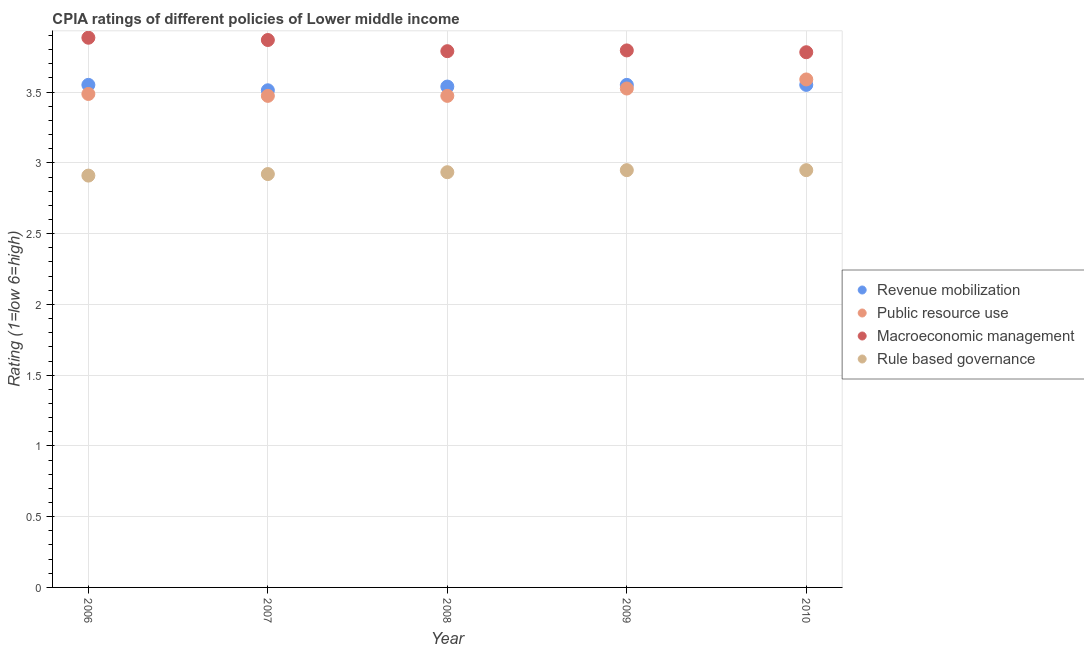What is the cpia rating of macroeconomic management in 2010?
Give a very brief answer. 3.78. Across all years, what is the maximum cpia rating of public resource use?
Your answer should be compact. 3.59. Across all years, what is the minimum cpia rating of revenue mobilization?
Your answer should be very brief. 3.51. In which year was the cpia rating of macroeconomic management maximum?
Keep it short and to the point. 2006. What is the total cpia rating of rule based governance in the graph?
Your answer should be compact. 14.66. What is the difference between the cpia rating of public resource use in 2008 and that in 2010?
Offer a very short reply. -0.12. What is the difference between the cpia rating of public resource use in 2007 and the cpia rating of macroeconomic management in 2009?
Give a very brief answer. -0.32. What is the average cpia rating of public resource use per year?
Your answer should be compact. 3.51. In the year 2007, what is the difference between the cpia rating of public resource use and cpia rating of macroeconomic management?
Provide a short and direct response. -0.39. What is the ratio of the cpia rating of rule based governance in 2007 to that in 2009?
Offer a terse response. 0.99. Is the cpia rating of macroeconomic management in 2006 less than that in 2007?
Offer a very short reply. No. Is the difference between the cpia rating of rule based governance in 2006 and 2010 greater than the difference between the cpia rating of macroeconomic management in 2006 and 2010?
Make the answer very short. No. What is the difference between the highest and the lowest cpia rating of rule based governance?
Offer a terse response. 0.04. Is it the case that in every year, the sum of the cpia rating of public resource use and cpia rating of rule based governance is greater than the sum of cpia rating of macroeconomic management and cpia rating of revenue mobilization?
Ensure brevity in your answer.  No. Is it the case that in every year, the sum of the cpia rating of revenue mobilization and cpia rating of public resource use is greater than the cpia rating of macroeconomic management?
Provide a short and direct response. Yes. How many years are there in the graph?
Keep it short and to the point. 5. Are the values on the major ticks of Y-axis written in scientific E-notation?
Offer a very short reply. No. How many legend labels are there?
Give a very brief answer. 4. How are the legend labels stacked?
Offer a very short reply. Vertical. What is the title of the graph?
Provide a short and direct response. CPIA ratings of different policies of Lower middle income. What is the label or title of the X-axis?
Give a very brief answer. Year. What is the label or title of the Y-axis?
Keep it short and to the point. Rating (1=low 6=high). What is the Rating (1=low 6=high) of Revenue mobilization in 2006?
Offer a very short reply. 3.55. What is the Rating (1=low 6=high) of Public resource use in 2006?
Keep it short and to the point. 3.49. What is the Rating (1=low 6=high) in Macroeconomic management in 2006?
Your answer should be compact. 3.88. What is the Rating (1=low 6=high) of Rule based governance in 2006?
Your response must be concise. 2.91. What is the Rating (1=low 6=high) of Revenue mobilization in 2007?
Offer a terse response. 3.51. What is the Rating (1=low 6=high) of Public resource use in 2007?
Your answer should be compact. 3.47. What is the Rating (1=low 6=high) in Macroeconomic management in 2007?
Ensure brevity in your answer.  3.87. What is the Rating (1=low 6=high) of Rule based governance in 2007?
Your response must be concise. 2.92. What is the Rating (1=low 6=high) in Revenue mobilization in 2008?
Offer a very short reply. 3.54. What is the Rating (1=low 6=high) in Public resource use in 2008?
Offer a very short reply. 3.47. What is the Rating (1=low 6=high) of Macroeconomic management in 2008?
Make the answer very short. 3.79. What is the Rating (1=low 6=high) of Rule based governance in 2008?
Your answer should be compact. 2.93. What is the Rating (1=low 6=high) of Revenue mobilization in 2009?
Keep it short and to the point. 3.55. What is the Rating (1=low 6=high) of Public resource use in 2009?
Offer a terse response. 3.53. What is the Rating (1=low 6=high) of Macroeconomic management in 2009?
Give a very brief answer. 3.79. What is the Rating (1=low 6=high) of Rule based governance in 2009?
Provide a short and direct response. 2.95. What is the Rating (1=low 6=high) of Revenue mobilization in 2010?
Ensure brevity in your answer.  3.55. What is the Rating (1=low 6=high) of Public resource use in 2010?
Offer a terse response. 3.59. What is the Rating (1=low 6=high) in Macroeconomic management in 2010?
Your answer should be compact. 3.78. What is the Rating (1=low 6=high) of Rule based governance in 2010?
Offer a terse response. 2.95. Across all years, what is the maximum Rating (1=low 6=high) in Revenue mobilization?
Ensure brevity in your answer.  3.55. Across all years, what is the maximum Rating (1=low 6=high) in Public resource use?
Give a very brief answer. 3.59. Across all years, what is the maximum Rating (1=low 6=high) in Macroeconomic management?
Offer a very short reply. 3.88. Across all years, what is the maximum Rating (1=low 6=high) of Rule based governance?
Your answer should be very brief. 2.95. Across all years, what is the minimum Rating (1=low 6=high) in Revenue mobilization?
Make the answer very short. 3.51. Across all years, what is the minimum Rating (1=low 6=high) in Public resource use?
Make the answer very short. 3.47. Across all years, what is the minimum Rating (1=low 6=high) in Macroeconomic management?
Make the answer very short. 3.78. Across all years, what is the minimum Rating (1=low 6=high) of Rule based governance?
Give a very brief answer. 2.91. What is the total Rating (1=low 6=high) of Revenue mobilization in the graph?
Your answer should be compact. 17.71. What is the total Rating (1=low 6=high) in Public resource use in the graph?
Give a very brief answer. 17.55. What is the total Rating (1=low 6=high) of Macroeconomic management in the graph?
Ensure brevity in your answer.  19.12. What is the total Rating (1=low 6=high) in Rule based governance in the graph?
Ensure brevity in your answer.  14.66. What is the difference between the Rating (1=low 6=high) of Revenue mobilization in 2006 and that in 2007?
Offer a very short reply. 0.04. What is the difference between the Rating (1=low 6=high) in Public resource use in 2006 and that in 2007?
Keep it short and to the point. 0.01. What is the difference between the Rating (1=low 6=high) in Macroeconomic management in 2006 and that in 2007?
Provide a short and direct response. 0.02. What is the difference between the Rating (1=low 6=high) of Rule based governance in 2006 and that in 2007?
Provide a succinct answer. -0.01. What is the difference between the Rating (1=low 6=high) of Revenue mobilization in 2006 and that in 2008?
Offer a very short reply. 0.01. What is the difference between the Rating (1=low 6=high) of Public resource use in 2006 and that in 2008?
Your response must be concise. 0.01. What is the difference between the Rating (1=low 6=high) of Macroeconomic management in 2006 and that in 2008?
Give a very brief answer. 0.1. What is the difference between the Rating (1=low 6=high) in Rule based governance in 2006 and that in 2008?
Keep it short and to the point. -0.02. What is the difference between the Rating (1=low 6=high) in Revenue mobilization in 2006 and that in 2009?
Make the answer very short. 0. What is the difference between the Rating (1=low 6=high) in Public resource use in 2006 and that in 2009?
Offer a very short reply. -0.04. What is the difference between the Rating (1=low 6=high) of Macroeconomic management in 2006 and that in 2009?
Offer a terse response. 0.09. What is the difference between the Rating (1=low 6=high) of Rule based governance in 2006 and that in 2009?
Your answer should be very brief. -0.04. What is the difference between the Rating (1=low 6=high) in Revenue mobilization in 2006 and that in 2010?
Keep it short and to the point. 0. What is the difference between the Rating (1=low 6=high) in Public resource use in 2006 and that in 2010?
Provide a short and direct response. -0.1. What is the difference between the Rating (1=low 6=high) of Macroeconomic management in 2006 and that in 2010?
Offer a terse response. 0.1. What is the difference between the Rating (1=low 6=high) of Rule based governance in 2006 and that in 2010?
Provide a short and direct response. -0.04. What is the difference between the Rating (1=low 6=high) in Revenue mobilization in 2007 and that in 2008?
Offer a terse response. -0.03. What is the difference between the Rating (1=low 6=high) in Macroeconomic management in 2007 and that in 2008?
Ensure brevity in your answer.  0.08. What is the difference between the Rating (1=low 6=high) of Rule based governance in 2007 and that in 2008?
Give a very brief answer. -0.01. What is the difference between the Rating (1=low 6=high) of Revenue mobilization in 2007 and that in 2009?
Make the answer very short. -0.04. What is the difference between the Rating (1=low 6=high) in Public resource use in 2007 and that in 2009?
Offer a very short reply. -0.05. What is the difference between the Rating (1=low 6=high) of Macroeconomic management in 2007 and that in 2009?
Ensure brevity in your answer.  0.07. What is the difference between the Rating (1=low 6=high) of Rule based governance in 2007 and that in 2009?
Give a very brief answer. -0.03. What is the difference between the Rating (1=low 6=high) of Revenue mobilization in 2007 and that in 2010?
Provide a short and direct response. -0.04. What is the difference between the Rating (1=low 6=high) in Public resource use in 2007 and that in 2010?
Provide a short and direct response. -0.12. What is the difference between the Rating (1=low 6=high) of Macroeconomic management in 2007 and that in 2010?
Offer a very short reply. 0.09. What is the difference between the Rating (1=low 6=high) in Rule based governance in 2007 and that in 2010?
Ensure brevity in your answer.  -0.03. What is the difference between the Rating (1=low 6=high) in Revenue mobilization in 2008 and that in 2009?
Ensure brevity in your answer.  -0.01. What is the difference between the Rating (1=low 6=high) in Public resource use in 2008 and that in 2009?
Your response must be concise. -0.05. What is the difference between the Rating (1=low 6=high) of Macroeconomic management in 2008 and that in 2009?
Your answer should be compact. -0.01. What is the difference between the Rating (1=low 6=high) in Rule based governance in 2008 and that in 2009?
Offer a terse response. -0.01. What is the difference between the Rating (1=low 6=high) in Revenue mobilization in 2008 and that in 2010?
Your response must be concise. -0.01. What is the difference between the Rating (1=low 6=high) of Public resource use in 2008 and that in 2010?
Offer a very short reply. -0.12. What is the difference between the Rating (1=low 6=high) of Macroeconomic management in 2008 and that in 2010?
Ensure brevity in your answer.  0.01. What is the difference between the Rating (1=low 6=high) in Rule based governance in 2008 and that in 2010?
Provide a succinct answer. -0.01. What is the difference between the Rating (1=low 6=high) in Revenue mobilization in 2009 and that in 2010?
Keep it short and to the point. 0. What is the difference between the Rating (1=low 6=high) of Public resource use in 2009 and that in 2010?
Offer a terse response. -0.06. What is the difference between the Rating (1=low 6=high) of Macroeconomic management in 2009 and that in 2010?
Give a very brief answer. 0.01. What is the difference between the Rating (1=low 6=high) in Revenue mobilization in 2006 and the Rating (1=low 6=high) in Public resource use in 2007?
Provide a succinct answer. 0.08. What is the difference between the Rating (1=low 6=high) of Revenue mobilization in 2006 and the Rating (1=low 6=high) of Macroeconomic management in 2007?
Your answer should be very brief. -0.32. What is the difference between the Rating (1=low 6=high) in Revenue mobilization in 2006 and the Rating (1=low 6=high) in Rule based governance in 2007?
Offer a very short reply. 0.63. What is the difference between the Rating (1=low 6=high) of Public resource use in 2006 and the Rating (1=low 6=high) of Macroeconomic management in 2007?
Provide a succinct answer. -0.38. What is the difference between the Rating (1=low 6=high) of Public resource use in 2006 and the Rating (1=low 6=high) of Rule based governance in 2007?
Keep it short and to the point. 0.57. What is the difference between the Rating (1=low 6=high) of Macroeconomic management in 2006 and the Rating (1=low 6=high) of Rule based governance in 2007?
Ensure brevity in your answer.  0.96. What is the difference between the Rating (1=low 6=high) of Revenue mobilization in 2006 and the Rating (1=low 6=high) of Public resource use in 2008?
Your answer should be very brief. 0.08. What is the difference between the Rating (1=low 6=high) of Revenue mobilization in 2006 and the Rating (1=low 6=high) of Macroeconomic management in 2008?
Give a very brief answer. -0.24. What is the difference between the Rating (1=low 6=high) in Revenue mobilization in 2006 and the Rating (1=low 6=high) in Rule based governance in 2008?
Make the answer very short. 0.62. What is the difference between the Rating (1=low 6=high) of Public resource use in 2006 and the Rating (1=low 6=high) of Macroeconomic management in 2008?
Your answer should be compact. -0.3. What is the difference between the Rating (1=low 6=high) in Public resource use in 2006 and the Rating (1=low 6=high) in Rule based governance in 2008?
Provide a short and direct response. 0.55. What is the difference between the Rating (1=low 6=high) of Macroeconomic management in 2006 and the Rating (1=low 6=high) of Rule based governance in 2008?
Your response must be concise. 0.95. What is the difference between the Rating (1=low 6=high) of Revenue mobilization in 2006 and the Rating (1=low 6=high) of Public resource use in 2009?
Your answer should be very brief. 0.03. What is the difference between the Rating (1=low 6=high) in Revenue mobilization in 2006 and the Rating (1=low 6=high) in Macroeconomic management in 2009?
Your answer should be compact. -0.24. What is the difference between the Rating (1=low 6=high) of Revenue mobilization in 2006 and the Rating (1=low 6=high) of Rule based governance in 2009?
Your response must be concise. 0.6. What is the difference between the Rating (1=low 6=high) in Public resource use in 2006 and the Rating (1=low 6=high) in Macroeconomic management in 2009?
Provide a succinct answer. -0.31. What is the difference between the Rating (1=low 6=high) in Public resource use in 2006 and the Rating (1=low 6=high) in Rule based governance in 2009?
Give a very brief answer. 0.54. What is the difference between the Rating (1=low 6=high) in Macroeconomic management in 2006 and the Rating (1=low 6=high) in Rule based governance in 2009?
Give a very brief answer. 0.94. What is the difference between the Rating (1=low 6=high) of Revenue mobilization in 2006 and the Rating (1=low 6=high) of Public resource use in 2010?
Your answer should be very brief. -0.04. What is the difference between the Rating (1=low 6=high) in Revenue mobilization in 2006 and the Rating (1=low 6=high) in Macroeconomic management in 2010?
Keep it short and to the point. -0.23. What is the difference between the Rating (1=low 6=high) of Revenue mobilization in 2006 and the Rating (1=low 6=high) of Rule based governance in 2010?
Offer a terse response. 0.6. What is the difference between the Rating (1=low 6=high) of Public resource use in 2006 and the Rating (1=low 6=high) of Macroeconomic management in 2010?
Your answer should be compact. -0.29. What is the difference between the Rating (1=low 6=high) in Public resource use in 2006 and the Rating (1=low 6=high) in Rule based governance in 2010?
Provide a succinct answer. 0.54. What is the difference between the Rating (1=low 6=high) of Macroeconomic management in 2006 and the Rating (1=low 6=high) of Rule based governance in 2010?
Your answer should be compact. 0.94. What is the difference between the Rating (1=low 6=high) of Revenue mobilization in 2007 and the Rating (1=low 6=high) of Public resource use in 2008?
Your answer should be very brief. 0.04. What is the difference between the Rating (1=low 6=high) of Revenue mobilization in 2007 and the Rating (1=low 6=high) of Macroeconomic management in 2008?
Offer a terse response. -0.28. What is the difference between the Rating (1=low 6=high) of Revenue mobilization in 2007 and the Rating (1=low 6=high) of Rule based governance in 2008?
Ensure brevity in your answer.  0.58. What is the difference between the Rating (1=low 6=high) in Public resource use in 2007 and the Rating (1=low 6=high) in Macroeconomic management in 2008?
Make the answer very short. -0.32. What is the difference between the Rating (1=low 6=high) of Public resource use in 2007 and the Rating (1=low 6=high) of Rule based governance in 2008?
Your answer should be compact. 0.54. What is the difference between the Rating (1=low 6=high) in Macroeconomic management in 2007 and the Rating (1=low 6=high) in Rule based governance in 2008?
Give a very brief answer. 0.93. What is the difference between the Rating (1=low 6=high) in Revenue mobilization in 2007 and the Rating (1=low 6=high) in Public resource use in 2009?
Your response must be concise. -0.01. What is the difference between the Rating (1=low 6=high) in Revenue mobilization in 2007 and the Rating (1=low 6=high) in Macroeconomic management in 2009?
Offer a very short reply. -0.28. What is the difference between the Rating (1=low 6=high) of Revenue mobilization in 2007 and the Rating (1=low 6=high) of Rule based governance in 2009?
Provide a succinct answer. 0.56. What is the difference between the Rating (1=low 6=high) of Public resource use in 2007 and the Rating (1=low 6=high) of Macroeconomic management in 2009?
Keep it short and to the point. -0.32. What is the difference between the Rating (1=low 6=high) of Public resource use in 2007 and the Rating (1=low 6=high) of Rule based governance in 2009?
Offer a terse response. 0.53. What is the difference between the Rating (1=low 6=high) in Macroeconomic management in 2007 and the Rating (1=low 6=high) in Rule based governance in 2009?
Give a very brief answer. 0.92. What is the difference between the Rating (1=low 6=high) in Revenue mobilization in 2007 and the Rating (1=low 6=high) in Public resource use in 2010?
Offer a very short reply. -0.08. What is the difference between the Rating (1=low 6=high) of Revenue mobilization in 2007 and the Rating (1=low 6=high) of Macroeconomic management in 2010?
Offer a terse response. -0.27. What is the difference between the Rating (1=low 6=high) in Revenue mobilization in 2007 and the Rating (1=low 6=high) in Rule based governance in 2010?
Give a very brief answer. 0.56. What is the difference between the Rating (1=low 6=high) in Public resource use in 2007 and the Rating (1=low 6=high) in Macroeconomic management in 2010?
Your answer should be very brief. -0.31. What is the difference between the Rating (1=low 6=high) of Public resource use in 2007 and the Rating (1=low 6=high) of Rule based governance in 2010?
Ensure brevity in your answer.  0.53. What is the difference between the Rating (1=low 6=high) in Macroeconomic management in 2007 and the Rating (1=low 6=high) in Rule based governance in 2010?
Your response must be concise. 0.92. What is the difference between the Rating (1=low 6=high) in Revenue mobilization in 2008 and the Rating (1=low 6=high) in Public resource use in 2009?
Your answer should be compact. 0.01. What is the difference between the Rating (1=low 6=high) of Revenue mobilization in 2008 and the Rating (1=low 6=high) of Macroeconomic management in 2009?
Provide a short and direct response. -0.26. What is the difference between the Rating (1=low 6=high) in Revenue mobilization in 2008 and the Rating (1=low 6=high) in Rule based governance in 2009?
Give a very brief answer. 0.59. What is the difference between the Rating (1=low 6=high) in Public resource use in 2008 and the Rating (1=low 6=high) in Macroeconomic management in 2009?
Make the answer very short. -0.32. What is the difference between the Rating (1=low 6=high) of Public resource use in 2008 and the Rating (1=low 6=high) of Rule based governance in 2009?
Offer a terse response. 0.53. What is the difference between the Rating (1=low 6=high) of Macroeconomic management in 2008 and the Rating (1=low 6=high) of Rule based governance in 2009?
Offer a terse response. 0.84. What is the difference between the Rating (1=low 6=high) of Revenue mobilization in 2008 and the Rating (1=low 6=high) of Public resource use in 2010?
Keep it short and to the point. -0.05. What is the difference between the Rating (1=low 6=high) of Revenue mobilization in 2008 and the Rating (1=low 6=high) of Macroeconomic management in 2010?
Your response must be concise. -0.24. What is the difference between the Rating (1=low 6=high) of Revenue mobilization in 2008 and the Rating (1=low 6=high) of Rule based governance in 2010?
Offer a terse response. 0.59. What is the difference between the Rating (1=low 6=high) in Public resource use in 2008 and the Rating (1=low 6=high) in Macroeconomic management in 2010?
Provide a short and direct response. -0.31. What is the difference between the Rating (1=low 6=high) of Public resource use in 2008 and the Rating (1=low 6=high) of Rule based governance in 2010?
Offer a terse response. 0.53. What is the difference between the Rating (1=low 6=high) of Macroeconomic management in 2008 and the Rating (1=low 6=high) of Rule based governance in 2010?
Your answer should be compact. 0.84. What is the difference between the Rating (1=low 6=high) in Revenue mobilization in 2009 and the Rating (1=low 6=high) in Public resource use in 2010?
Offer a very short reply. -0.04. What is the difference between the Rating (1=low 6=high) of Revenue mobilization in 2009 and the Rating (1=low 6=high) of Macroeconomic management in 2010?
Give a very brief answer. -0.23. What is the difference between the Rating (1=low 6=high) of Revenue mobilization in 2009 and the Rating (1=low 6=high) of Rule based governance in 2010?
Offer a terse response. 0.6. What is the difference between the Rating (1=low 6=high) of Public resource use in 2009 and the Rating (1=low 6=high) of Macroeconomic management in 2010?
Your response must be concise. -0.26. What is the difference between the Rating (1=low 6=high) in Public resource use in 2009 and the Rating (1=low 6=high) in Rule based governance in 2010?
Make the answer very short. 0.58. What is the difference between the Rating (1=low 6=high) in Macroeconomic management in 2009 and the Rating (1=low 6=high) in Rule based governance in 2010?
Ensure brevity in your answer.  0.85. What is the average Rating (1=low 6=high) in Revenue mobilization per year?
Provide a succinct answer. 3.54. What is the average Rating (1=low 6=high) in Public resource use per year?
Your answer should be compact. 3.51. What is the average Rating (1=low 6=high) of Macroeconomic management per year?
Your answer should be very brief. 3.82. What is the average Rating (1=low 6=high) of Rule based governance per year?
Ensure brevity in your answer.  2.93. In the year 2006, what is the difference between the Rating (1=low 6=high) of Revenue mobilization and Rating (1=low 6=high) of Public resource use?
Your response must be concise. 0.06. In the year 2006, what is the difference between the Rating (1=low 6=high) in Revenue mobilization and Rating (1=low 6=high) in Rule based governance?
Ensure brevity in your answer.  0.64. In the year 2006, what is the difference between the Rating (1=low 6=high) in Public resource use and Rating (1=low 6=high) in Macroeconomic management?
Ensure brevity in your answer.  -0.4. In the year 2006, what is the difference between the Rating (1=low 6=high) in Public resource use and Rating (1=low 6=high) in Rule based governance?
Offer a terse response. 0.58. In the year 2006, what is the difference between the Rating (1=low 6=high) in Macroeconomic management and Rating (1=low 6=high) in Rule based governance?
Provide a short and direct response. 0.97. In the year 2007, what is the difference between the Rating (1=low 6=high) of Revenue mobilization and Rating (1=low 6=high) of Public resource use?
Provide a succinct answer. 0.04. In the year 2007, what is the difference between the Rating (1=low 6=high) in Revenue mobilization and Rating (1=low 6=high) in Macroeconomic management?
Your response must be concise. -0.36. In the year 2007, what is the difference between the Rating (1=low 6=high) of Revenue mobilization and Rating (1=low 6=high) of Rule based governance?
Offer a very short reply. 0.59. In the year 2007, what is the difference between the Rating (1=low 6=high) in Public resource use and Rating (1=low 6=high) in Macroeconomic management?
Keep it short and to the point. -0.39. In the year 2007, what is the difference between the Rating (1=low 6=high) of Public resource use and Rating (1=low 6=high) of Rule based governance?
Your answer should be compact. 0.55. In the year 2007, what is the difference between the Rating (1=low 6=high) in Macroeconomic management and Rating (1=low 6=high) in Rule based governance?
Keep it short and to the point. 0.95. In the year 2008, what is the difference between the Rating (1=low 6=high) of Revenue mobilization and Rating (1=low 6=high) of Public resource use?
Give a very brief answer. 0.07. In the year 2008, what is the difference between the Rating (1=low 6=high) in Revenue mobilization and Rating (1=low 6=high) in Rule based governance?
Your answer should be very brief. 0.61. In the year 2008, what is the difference between the Rating (1=low 6=high) of Public resource use and Rating (1=low 6=high) of Macroeconomic management?
Your answer should be compact. -0.32. In the year 2008, what is the difference between the Rating (1=low 6=high) in Public resource use and Rating (1=low 6=high) in Rule based governance?
Your response must be concise. 0.54. In the year 2008, what is the difference between the Rating (1=low 6=high) of Macroeconomic management and Rating (1=low 6=high) of Rule based governance?
Ensure brevity in your answer.  0.86. In the year 2009, what is the difference between the Rating (1=low 6=high) of Revenue mobilization and Rating (1=low 6=high) of Public resource use?
Provide a succinct answer. 0.03. In the year 2009, what is the difference between the Rating (1=low 6=high) of Revenue mobilization and Rating (1=low 6=high) of Macroeconomic management?
Your answer should be compact. -0.24. In the year 2009, what is the difference between the Rating (1=low 6=high) in Revenue mobilization and Rating (1=low 6=high) in Rule based governance?
Your answer should be compact. 0.6. In the year 2009, what is the difference between the Rating (1=low 6=high) in Public resource use and Rating (1=low 6=high) in Macroeconomic management?
Offer a very short reply. -0.27. In the year 2009, what is the difference between the Rating (1=low 6=high) of Public resource use and Rating (1=low 6=high) of Rule based governance?
Your response must be concise. 0.58. In the year 2009, what is the difference between the Rating (1=low 6=high) of Macroeconomic management and Rating (1=low 6=high) of Rule based governance?
Your response must be concise. 0.85. In the year 2010, what is the difference between the Rating (1=low 6=high) in Revenue mobilization and Rating (1=low 6=high) in Public resource use?
Your answer should be very brief. -0.04. In the year 2010, what is the difference between the Rating (1=low 6=high) of Revenue mobilization and Rating (1=low 6=high) of Macroeconomic management?
Provide a succinct answer. -0.23. In the year 2010, what is the difference between the Rating (1=low 6=high) of Revenue mobilization and Rating (1=low 6=high) of Rule based governance?
Offer a very short reply. 0.6. In the year 2010, what is the difference between the Rating (1=low 6=high) of Public resource use and Rating (1=low 6=high) of Macroeconomic management?
Provide a short and direct response. -0.19. In the year 2010, what is the difference between the Rating (1=low 6=high) in Public resource use and Rating (1=low 6=high) in Rule based governance?
Offer a terse response. 0.64. What is the ratio of the Rating (1=low 6=high) of Revenue mobilization in 2006 to that in 2007?
Your response must be concise. 1.01. What is the ratio of the Rating (1=low 6=high) in Public resource use in 2006 to that in 2007?
Your response must be concise. 1. What is the ratio of the Rating (1=low 6=high) in Revenue mobilization in 2006 to that in 2008?
Provide a succinct answer. 1. What is the ratio of the Rating (1=low 6=high) in Macroeconomic management in 2006 to that in 2008?
Your answer should be compact. 1.03. What is the ratio of the Rating (1=low 6=high) in Rule based governance in 2006 to that in 2008?
Your answer should be compact. 0.99. What is the ratio of the Rating (1=low 6=high) of Revenue mobilization in 2006 to that in 2009?
Give a very brief answer. 1. What is the ratio of the Rating (1=low 6=high) in Macroeconomic management in 2006 to that in 2009?
Give a very brief answer. 1.02. What is the ratio of the Rating (1=low 6=high) of Rule based governance in 2006 to that in 2009?
Keep it short and to the point. 0.99. What is the ratio of the Rating (1=low 6=high) in Revenue mobilization in 2006 to that in 2010?
Your response must be concise. 1. What is the ratio of the Rating (1=low 6=high) in Public resource use in 2006 to that in 2010?
Keep it short and to the point. 0.97. What is the ratio of the Rating (1=low 6=high) of Macroeconomic management in 2006 to that in 2010?
Provide a succinct answer. 1.03. What is the ratio of the Rating (1=low 6=high) of Rule based governance in 2006 to that in 2010?
Make the answer very short. 0.99. What is the ratio of the Rating (1=low 6=high) in Revenue mobilization in 2007 to that in 2008?
Offer a very short reply. 0.99. What is the ratio of the Rating (1=low 6=high) in Public resource use in 2007 to that in 2008?
Your response must be concise. 1. What is the ratio of the Rating (1=low 6=high) of Macroeconomic management in 2007 to that in 2008?
Offer a very short reply. 1.02. What is the ratio of the Rating (1=low 6=high) in Revenue mobilization in 2007 to that in 2009?
Make the answer very short. 0.99. What is the ratio of the Rating (1=low 6=high) of Macroeconomic management in 2007 to that in 2009?
Your answer should be compact. 1.02. What is the ratio of the Rating (1=low 6=high) in Rule based governance in 2007 to that in 2009?
Your answer should be very brief. 0.99. What is the ratio of the Rating (1=low 6=high) in Revenue mobilization in 2007 to that in 2010?
Your answer should be very brief. 0.99. What is the ratio of the Rating (1=low 6=high) in Public resource use in 2007 to that in 2010?
Offer a very short reply. 0.97. What is the ratio of the Rating (1=low 6=high) of Macroeconomic management in 2007 to that in 2010?
Offer a terse response. 1.02. What is the ratio of the Rating (1=low 6=high) in Rule based governance in 2007 to that in 2010?
Make the answer very short. 0.99. What is the ratio of the Rating (1=low 6=high) of Revenue mobilization in 2008 to that in 2010?
Give a very brief answer. 1. What is the ratio of the Rating (1=low 6=high) of Rule based governance in 2008 to that in 2010?
Offer a terse response. 1. What is the ratio of the Rating (1=low 6=high) of Public resource use in 2009 to that in 2010?
Give a very brief answer. 0.98. What is the ratio of the Rating (1=low 6=high) of Macroeconomic management in 2009 to that in 2010?
Give a very brief answer. 1. What is the difference between the highest and the second highest Rating (1=low 6=high) in Public resource use?
Offer a terse response. 0.06. What is the difference between the highest and the second highest Rating (1=low 6=high) of Macroeconomic management?
Give a very brief answer. 0.02. What is the difference between the highest and the second highest Rating (1=low 6=high) of Rule based governance?
Keep it short and to the point. 0. What is the difference between the highest and the lowest Rating (1=low 6=high) of Revenue mobilization?
Offer a very short reply. 0.04. What is the difference between the highest and the lowest Rating (1=low 6=high) in Public resource use?
Your answer should be very brief. 0.12. What is the difference between the highest and the lowest Rating (1=low 6=high) in Macroeconomic management?
Your response must be concise. 0.1. What is the difference between the highest and the lowest Rating (1=low 6=high) in Rule based governance?
Give a very brief answer. 0.04. 